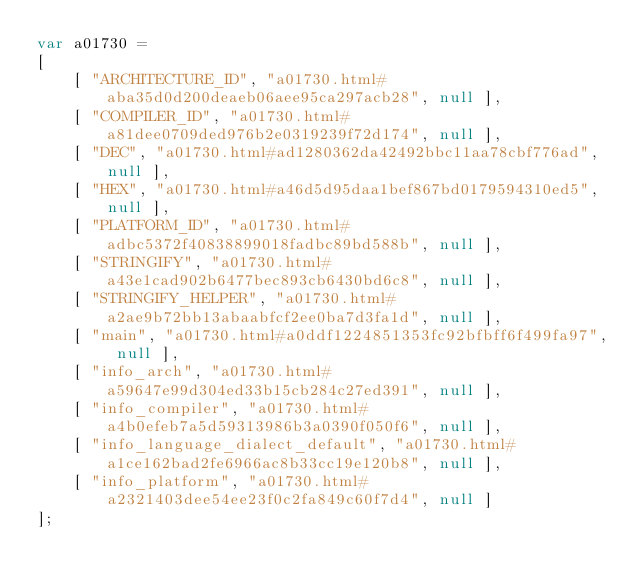Convert code to text. <code><loc_0><loc_0><loc_500><loc_500><_JavaScript_>var a01730 =
[
    [ "ARCHITECTURE_ID", "a01730.html#aba35d0d200deaeb06aee95ca297acb28", null ],
    [ "COMPILER_ID", "a01730.html#a81dee0709ded976b2e0319239f72d174", null ],
    [ "DEC", "a01730.html#ad1280362da42492bbc11aa78cbf776ad", null ],
    [ "HEX", "a01730.html#a46d5d95daa1bef867bd0179594310ed5", null ],
    [ "PLATFORM_ID", "a01730.html#adbc5372f40838899018fadbc89bd588b", null ],
    [ "STRINGIFY", "a01730.html#a43e1cad902b6477bec893cb6430bd6c8", null ],
    [ "STRINGIFY_HELPER", "a01730.html#a2ae9b72bb13abaabfcf2ee0ba7d3fa1d", null ],
    [ "main", "a01730.html#a0ddf1224851353fc92bfbff6f499fa97", null ],
    [ "info_arch", "a01730.html#a59647e99d304ed33b15cb284c27ed391", null ],
    [ "info_compiler", "a01730.html#a4b0efeb7a5d59313986b3a0390f050f6", null ],
    [ "info_language_dialect_default", "a01730.html#a1ce162bad2fe6966ac8b33cc19e120b8", null ],
    [ "info_platform", "a01730.html#a2321403dee54ee23f0c2fa849c60f7d4", null ]
];</code> 